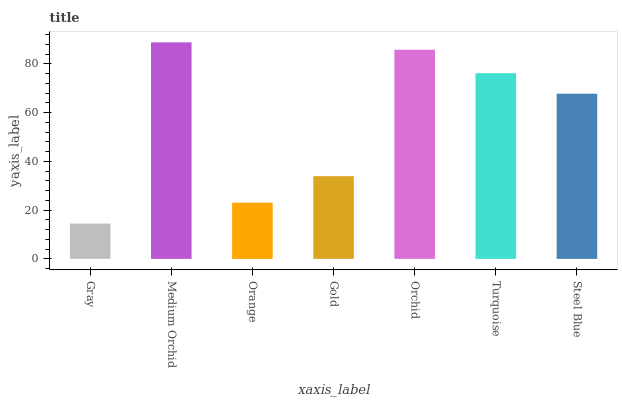Is Gray the minimum?
Answer yes or no. Yes. Is Medium Orchid the maximum?
Answer yes or no. Yes. Is Orange the minimum?
Answer yes or no. No. Is Orange the maximum?
Answer yes or no. No. Is Medium Orchid greater than Orange?
Answer yes or no. Yes. Is Orange less than Medium Orchid?
Answer yes or no. Yes. Is Orange greater than Medium Orchid?
Answer yes or no. No. Is Medium Orchid less than Orange?
Answer yes or no. No. Is Steel Blue the high median?
Answer yes or no. Yes. Is Steel Blue the low median?
Answer yes or no. Yes. Is Orchid the high median?
Answer yes or no. No. Is Gray the low median?
Answer yes or no. No. 